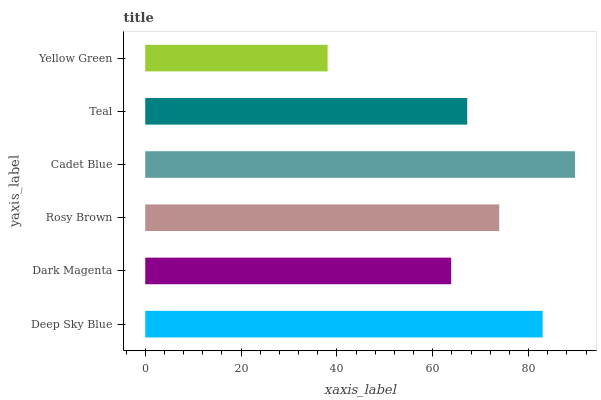Is Yellow Green the minimum?
Answer yes or no. Yes. Is Cadet Blue the maximum?
Answer yes or no. Yes. Is Dark Magenta the minimum?
Answer yes or no. No. Is Dark Magenta the maximum?
Answer yes or no. No. Is Deep Sky Blue greater than Dark Magenta?
Answer yes or no. Yes. Is Dark Magenta less than Deep Sky Blue?
Answer yes or no. Yes. Is Dark Magenta greater than Deep Sky Blue?
Answer yes or no. No. Is Deep Sky Blue less than Dark Magenta?
Answer yes or no. No. Is Rosy Brown the high median?
Answer yes or no. Yes. Is Teal the low median?
Answer yes or no. Yes. Is Yellow Green the high median?
Answer yes or no. No. Is Dark Magenta the low median?
Answer yes or no. No. 